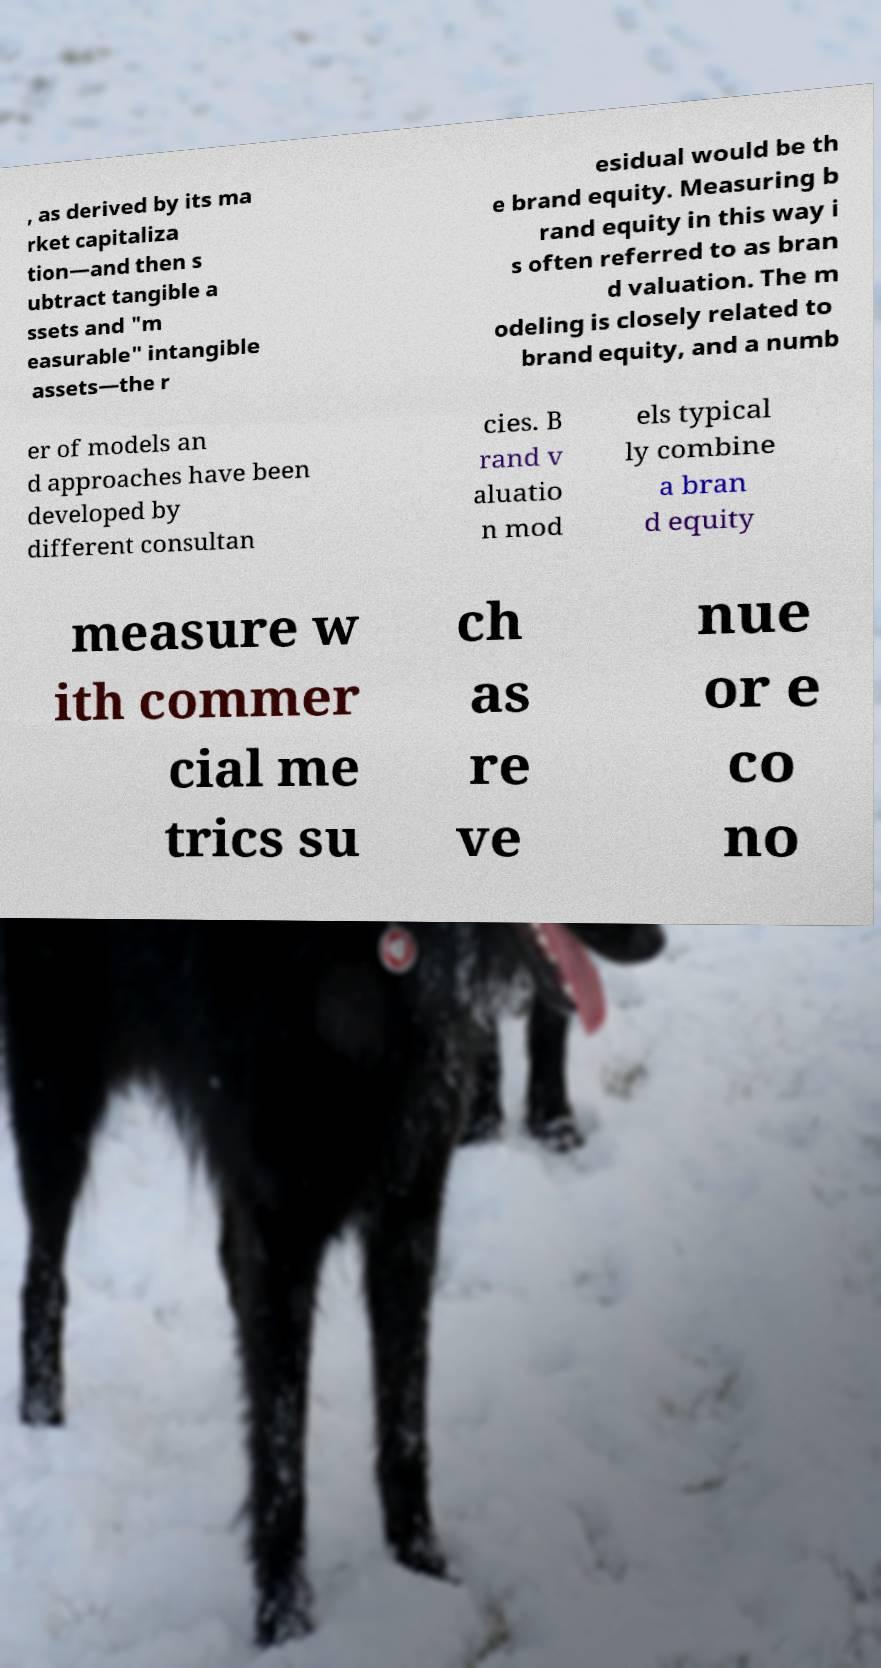There's text embedded in this image that I need extracted. Can you transcribe it verbatim? , as derived by its ma rket capitaliza tion—and then s ubtract tangible a ssets and "m easurable" intangible assets—the r esidual would be th e brand equity. Measuring b rand equity in this way i s often referred to as bran d valuation. The m odeling is closely related to brand equity, and a numb er of models an d approaches have been developed by different consultan cies. B rand v aluatio n mod els typical ly combine a bran d equity measure w ith commer cial me trics su ch as re ve nue or e co no 